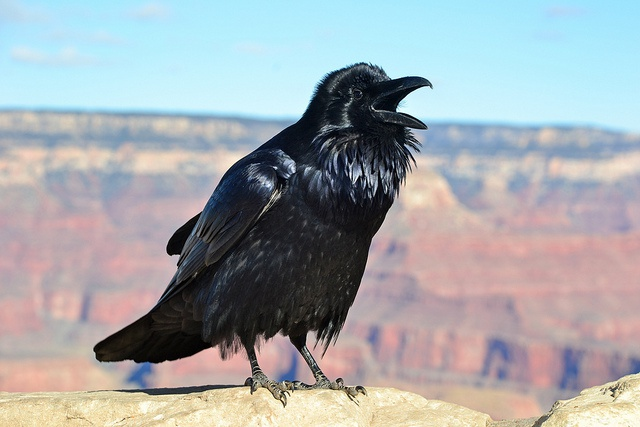Describe the objects in this image and their specific colors. I can see a bird in lightblue, black, gray, and darkgray tones in this image. 